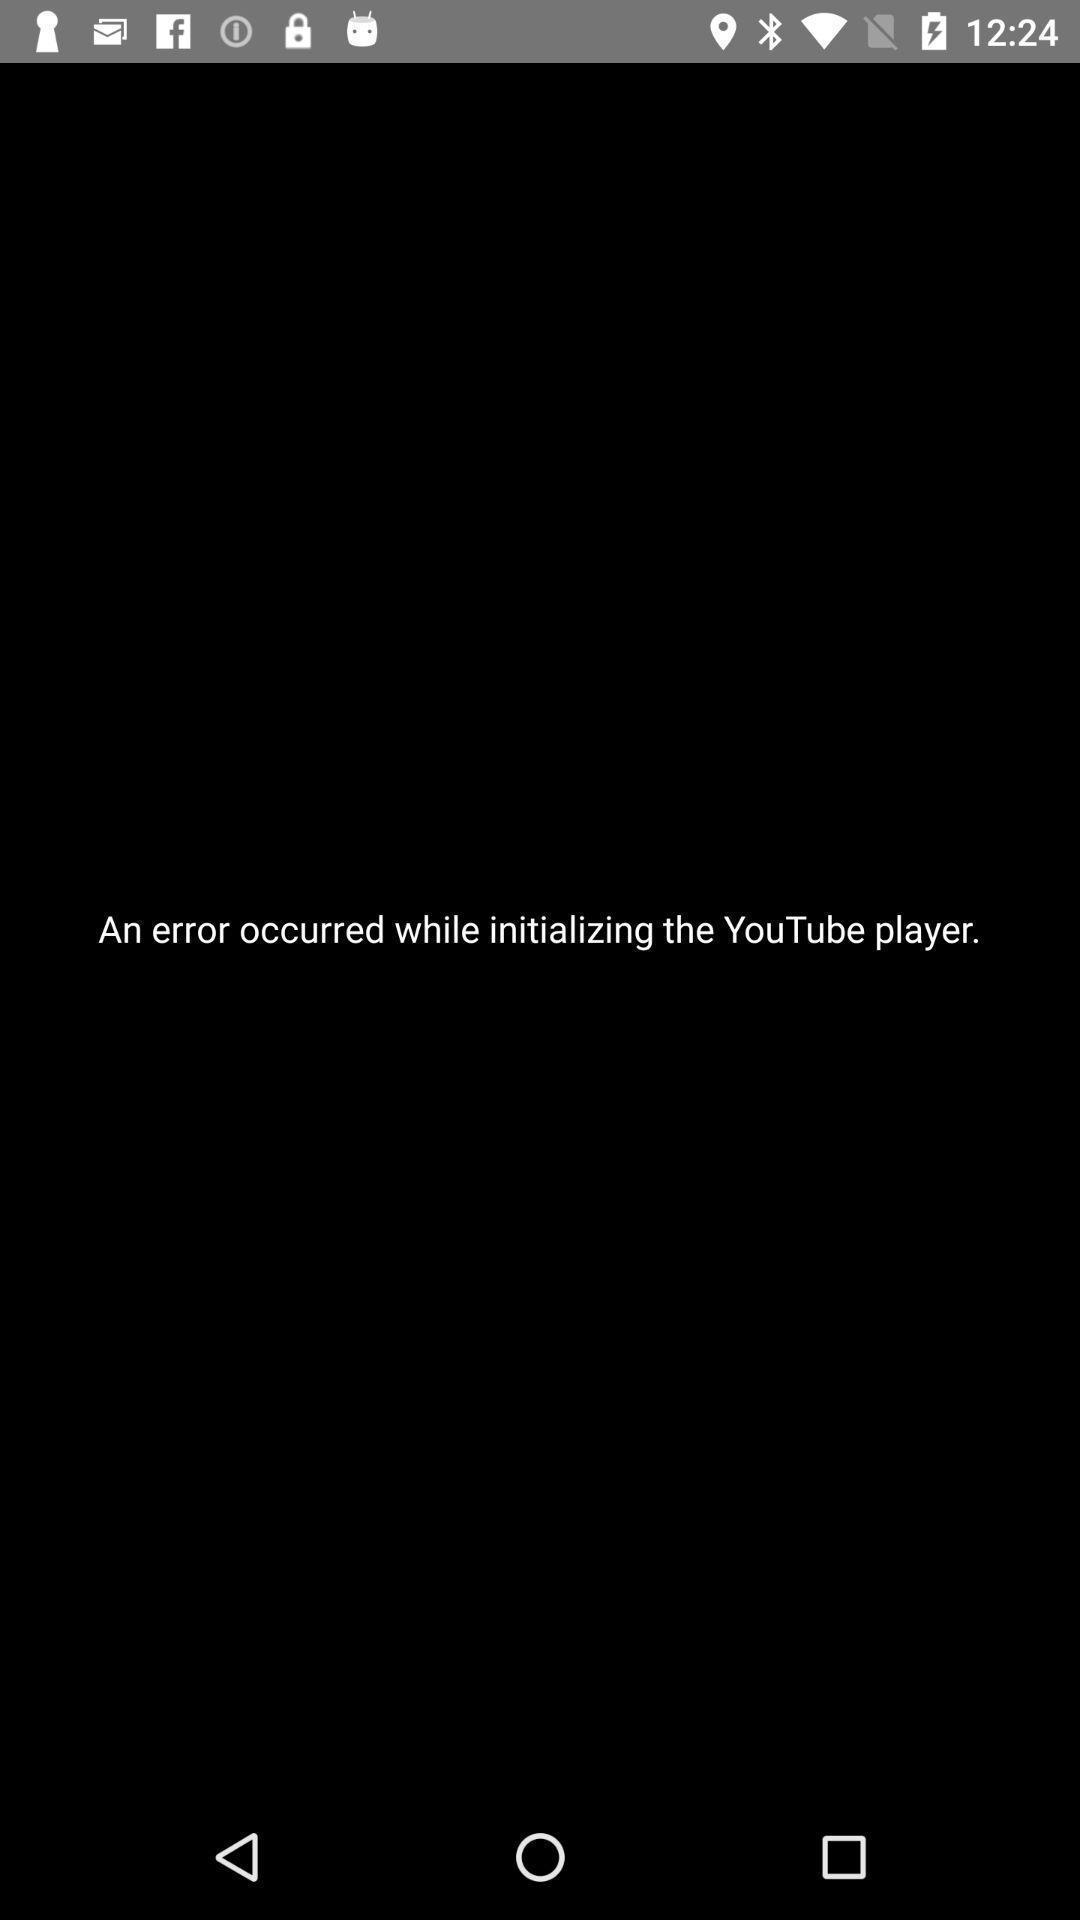Provide a textual representation of this image. Screen displaying the error page. 